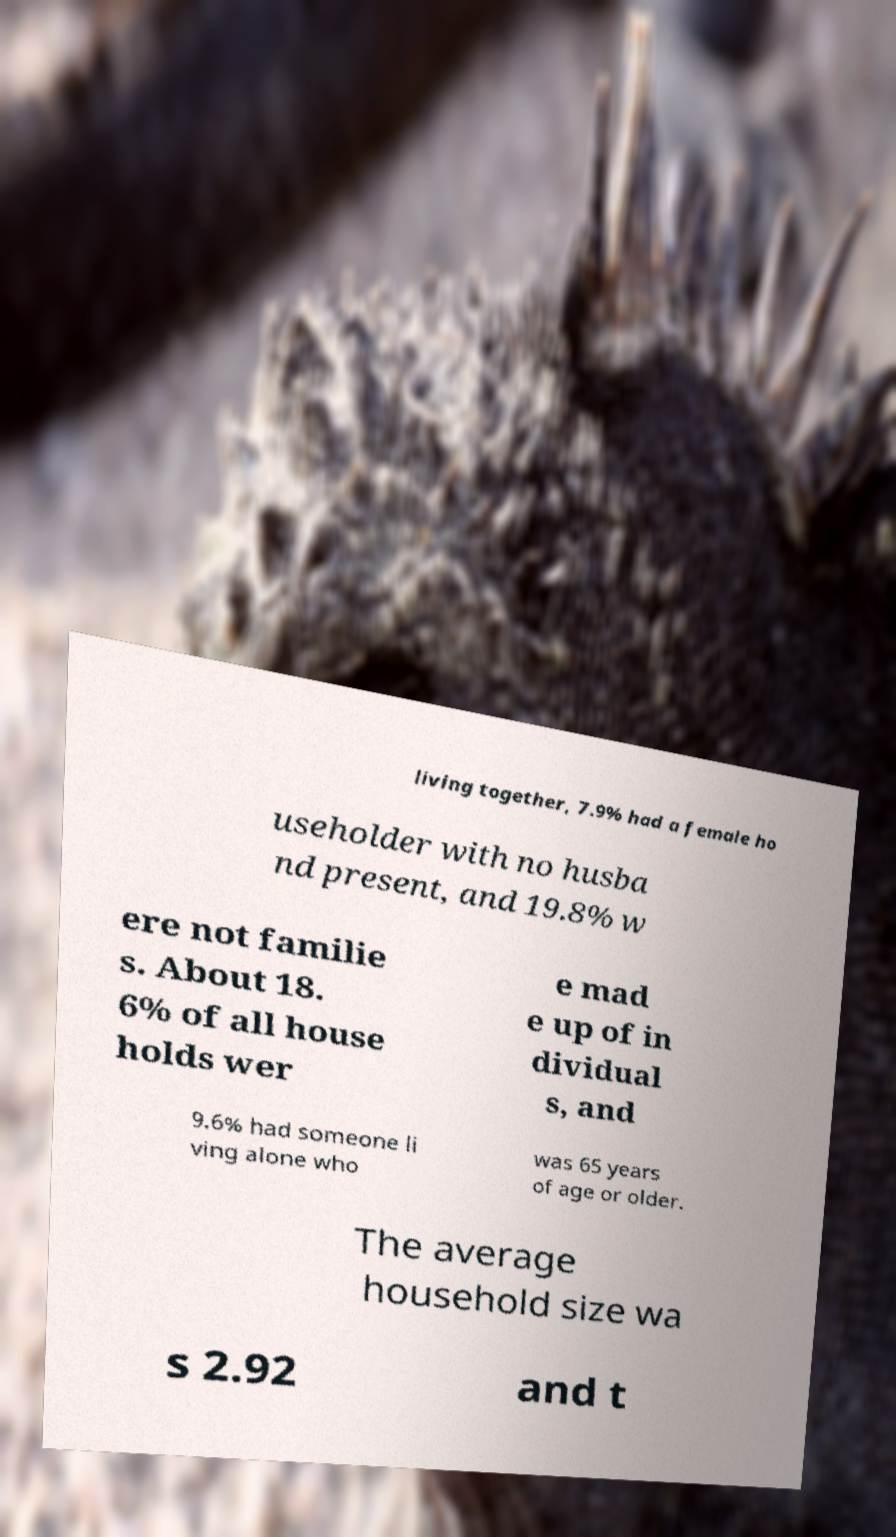Could you assist in decoding the text presented in this image and type it out clearly? living together, 7.9% had a female ho useholder with no husba nd present, and 19.8% w ere not familie s. About 18. 6% of all house holds wer e mad e up of in dividual s, and 9.6% had someone li ving alone who was 65 years of age or older. The average household size wa s 2.92 and t 